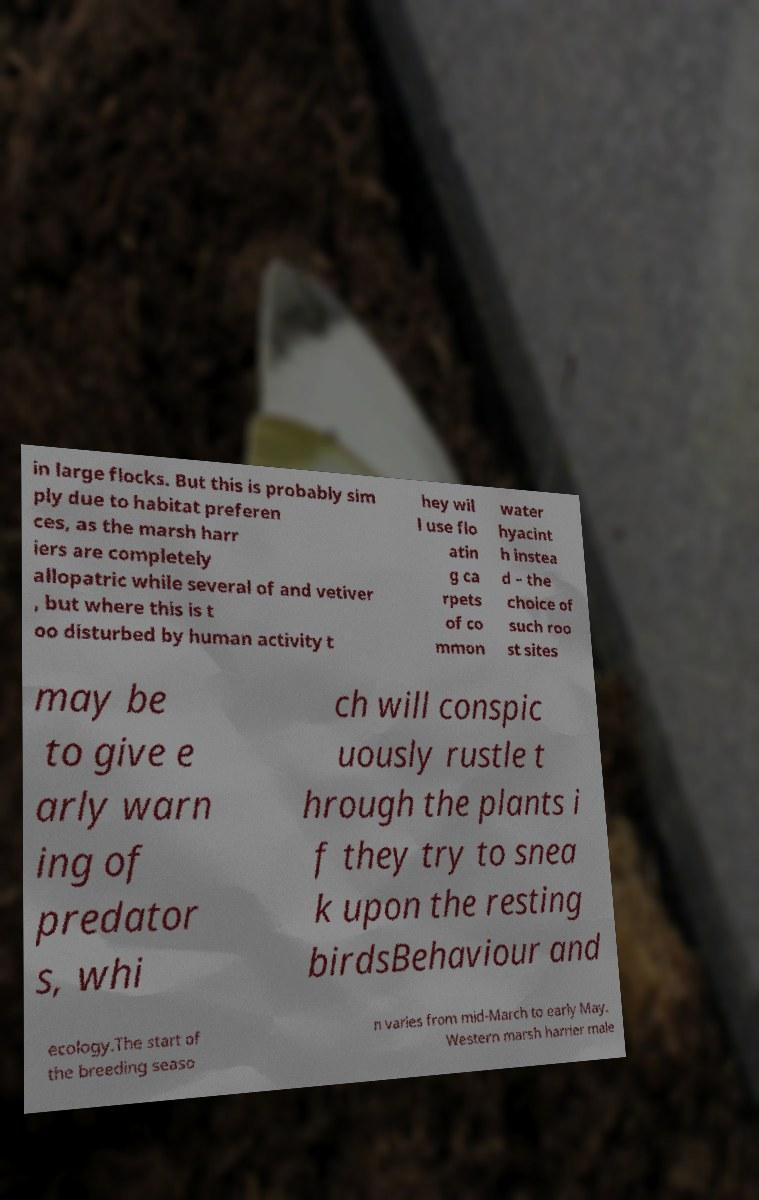There's text embedded in this image that I need extracted. Can you transcribe it verbatim? in large flocks. But this is probably sim ply due to habitat preferen ces, as the marsh harr iers are completely allopatric while several of and vetiver , but where this is t oo disturbed by human activity t hey wil l use flo atin g ca rpets of co mmon water hyacint h instea d – the choice of such roo st sites may be to give e arly warn ing of predator s, whi ch will conspic uously rustle t hrough the plants i f they try to snea k upon the resting birdsBehaviour and ecology.The start of the breeding seaso n varies from mid-March to early May. Western marsh harrier male 